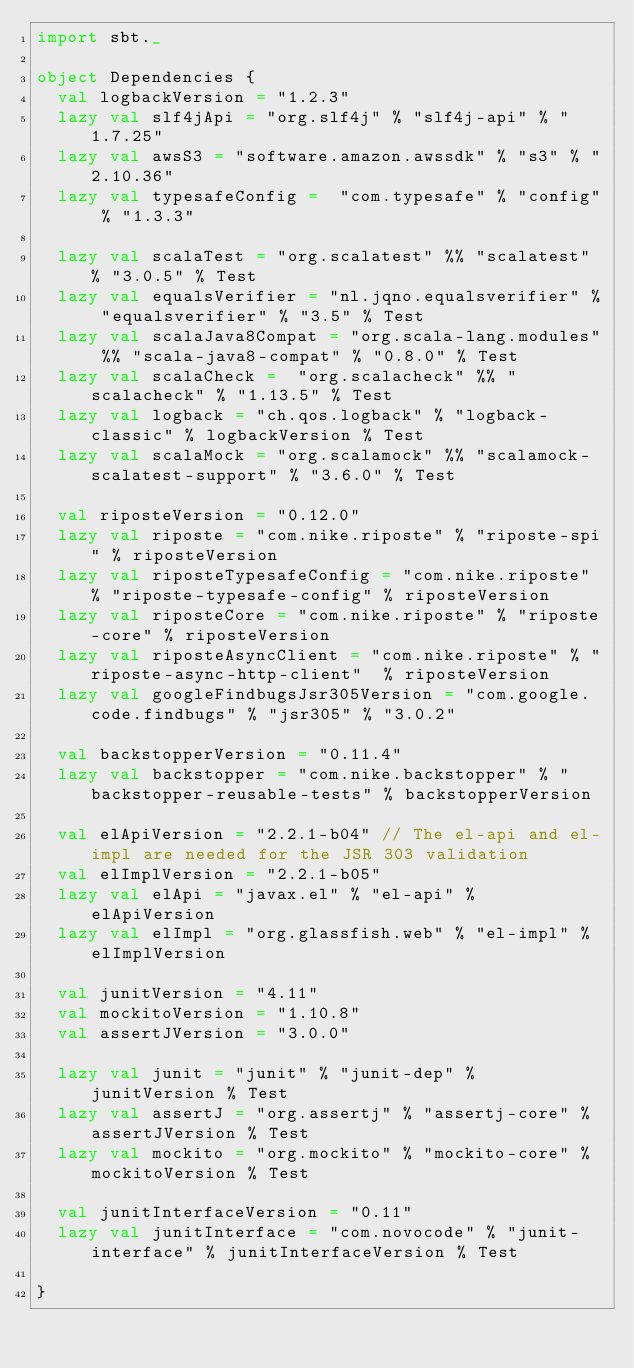Convert code to text. <code><loc_0><loc_0><loc_500><loc_500><_Scala_>import sbt._

object Dependencies {
  val logbackVersion = "1.2.3"
  lazy val slf4jApi = "org.slf4j" % "slf4j-api" % "1.7.25"
  lazy val awsS3 = "software.amazon.awssdk" % "s3" % "2.10.36"
  lazy val typesafeConfig =  "com.typesafe" % "config" % "1.3.3"

  lazy val scalaTest = "org.scalatest" %% "scalatest" % "3.0.5" % Test
  lazy val equalsVerifier = "nl.jqno.equalsverifier" % "equalsverifier" % "3.5" % Test
  lazy val scalaJava8Compat = "org.scala-lang.modules" %% "scala-java8-compat" % "0.8.0" % Test
  lazy val scalaCheck =  "org.scalacheck" %% "scalacheck" % "1.13.5" % Test
  lazy val logback = "ch.qos.logback" % "logback-classic" % logbackVersion % Test
  lazy val scalaMock = "org.scalamock" %% "scalamock-scalatest-support" % "3.6.0" % Test

  val riposteVersion = "0.12.0"
  lazy val riposte = "com.nike.riposte" % "riposte-spi" % riposteVersion
  lazy val riposteTypesafeConfig = "com.nike.riposte" % "riposte-typesafe-config" % riposteVersion
  lazy val riposteCore = "com.nike.riposte" % "riposte-core" % riposteVersion
  lazy val riposteAsyncClient = "com.nike.riposte" % "riposte-async-http-client"  % riposteVersion
  lazy val googleFindbugsJsr305Version = "com.google.code.findbugs" % "jsr305" % "3.0.2"

  val backstopperVersion = "0.11.4"
  lazy val backstopper = "com.nike.backstopper" % "backstopper-reusable-tests" % backstopperVersion

  val elApiVersion = "2.2.1-b04" // The el-api and el-impl are needed for the JSR 303 validation
  val elImplVersion = "2.2.1-b05"
  lazy val elApi = "javax.el" % "el-api" % elApiVersion
  lazy val elImpl = "org.glassfish.web" % "el-impl" % elImplVersion

  val junitVersion = "4.11"
  val mockitoVersion = "1.10.8"
  val assertJVersion = "3.0.0"

  lazy val junit = "junit" % "junit-dep" % junitVersion % Test
  lazy val assertJ = "org.assertj" % "assertj-core" % assertJVersion % Test
  lazy val mockito = "org.mockito" % "mockito-core" % mockitoVersion % Test

  val junitInterfaceVersion = "0.11"
  lazy val junitInterface = "com.novocode" % "junit-interface" % junitInterfaceVersion % Test

}

</code> 